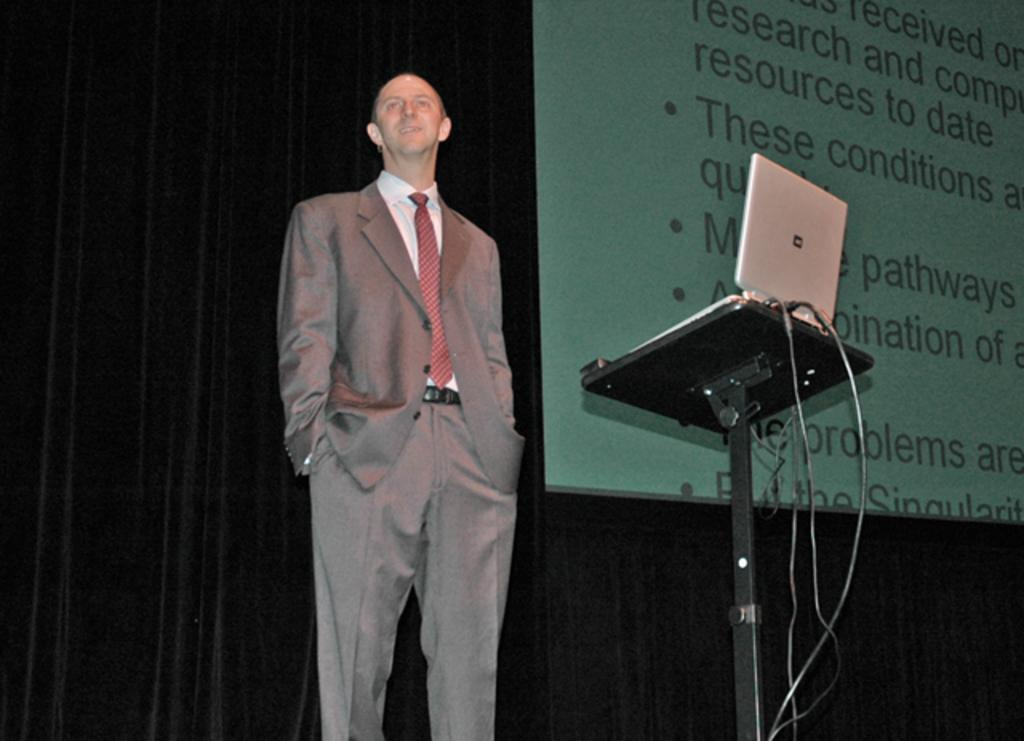Who is present in the image? There is a man in the image. What is the man's position in relation to the table? The man is standing in front of a table. What object is on the table? There is a laptop on the table. What is being displayed behind the man? A presentation is being displayed behind the man. What type of pear is being used as a musical instrument in the image? There is no pear or musical instrument present in the image. How does the turkey contribute to the presentation being displayed behind the man? There is no turkey present in the image, and therefore it cannot contribute to the presentation. 